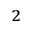Convert formula to latex. <formula><loc_0><loc_0><loc_500><loc_500>^ { 2 }</formula> 